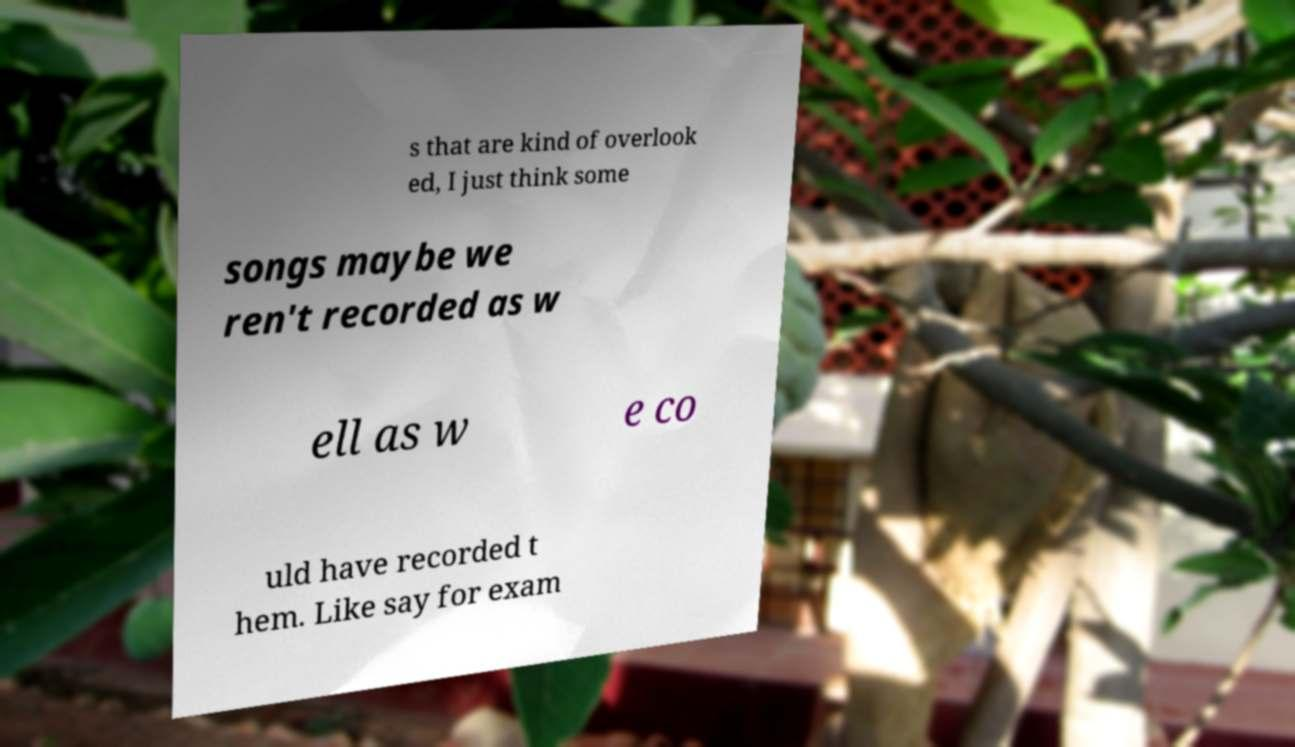Please identify and transcribe the text found in this image. s that are kind of overlook ed, I just think some songs maybe we ren't recorded as w ell as w e co uld have recorded t hem. Like say for exam 